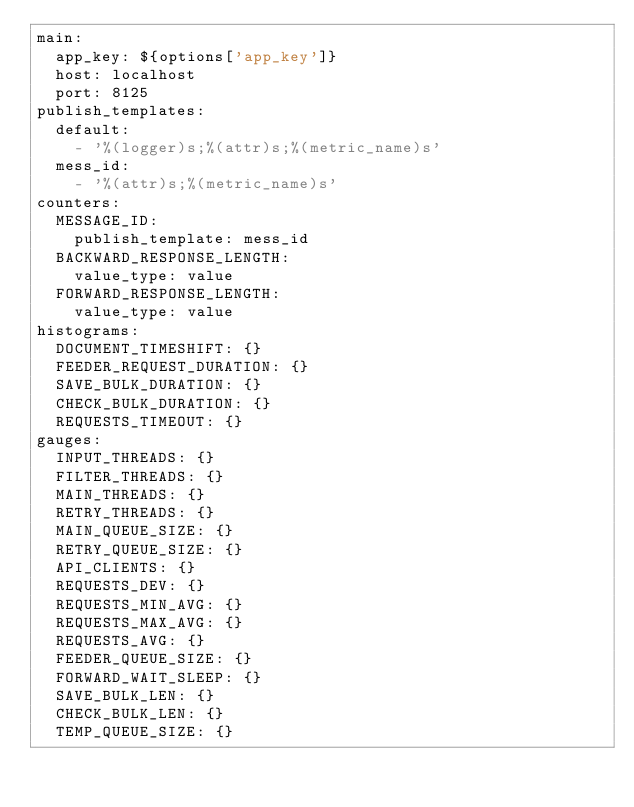<code> <loc_0><loc_0><loc_500><loc_500><_YAML_>main:
  app_key: ${options['app_key']}
  host: localhost
  port: 8125
publish_templates:
  default:
    - '%(logger)s;%(attr)s;%(metric_name)s'
  mess_id:
    - '%(attr)s;%(metric_name)s'
counters:
  MESSAGE_ID:
    publish_template: mess_id
  BACKWARD_RESPONSE_LENGTH:
    value_type: value
  FORWARD_RESPONSE_LENGTH:
    value_type: value
histograms:
  DOCUMENT_TIMESHIFT: {}
  FEEDER_REQUEST_DURATION: {}
  SAVE_BULK_DURATION: {}
  CHECK_BULK_DURATION: {}
  REQUESTS_TIMEOUT: {}
gauges:
  INPUT_THREADS: {}
  FILTER_THREADS: {}
  MAIN_THREADS: {}
  RETRY_THREADS: {}
  MAIN_QUEUE_SIZE: {}
  RETRY_QUEUE_SIZE: {}
  API_CLIENTS: {}
  REQUESTS_DEV: {}
  REQUESTS_MIN_AVG: {}
  REQUESTS_MAX_AVG: {}
  REQUESTS_AVG: {}
  FEEDER_QUEUE_SIZE: {}
  FORWARD_WAIT_SLEEP: {}
  SAVE_BULK_LEN: {}
  CHECK_BULK_LEN: {}
  TEMP_QUEUE_SIZE: {}</code> 